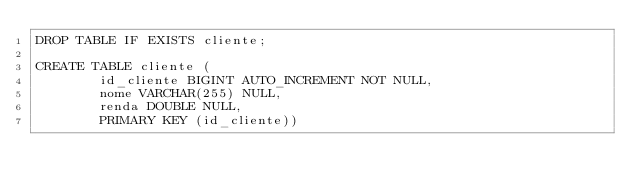<code> <loc_0><loc_0><loc_500><loc_500><_SQL_>DROP TABLE IF EXISTS cliente;

CREATE TABLE cliente (
        id_cliente BIGINT AUTO_INCREMENT NOT NULL,
        nome VARCHAR(255) NULL,
        renda DOUBLE NULL,
        PRIMARY KEY (id_cliente))
</code> 